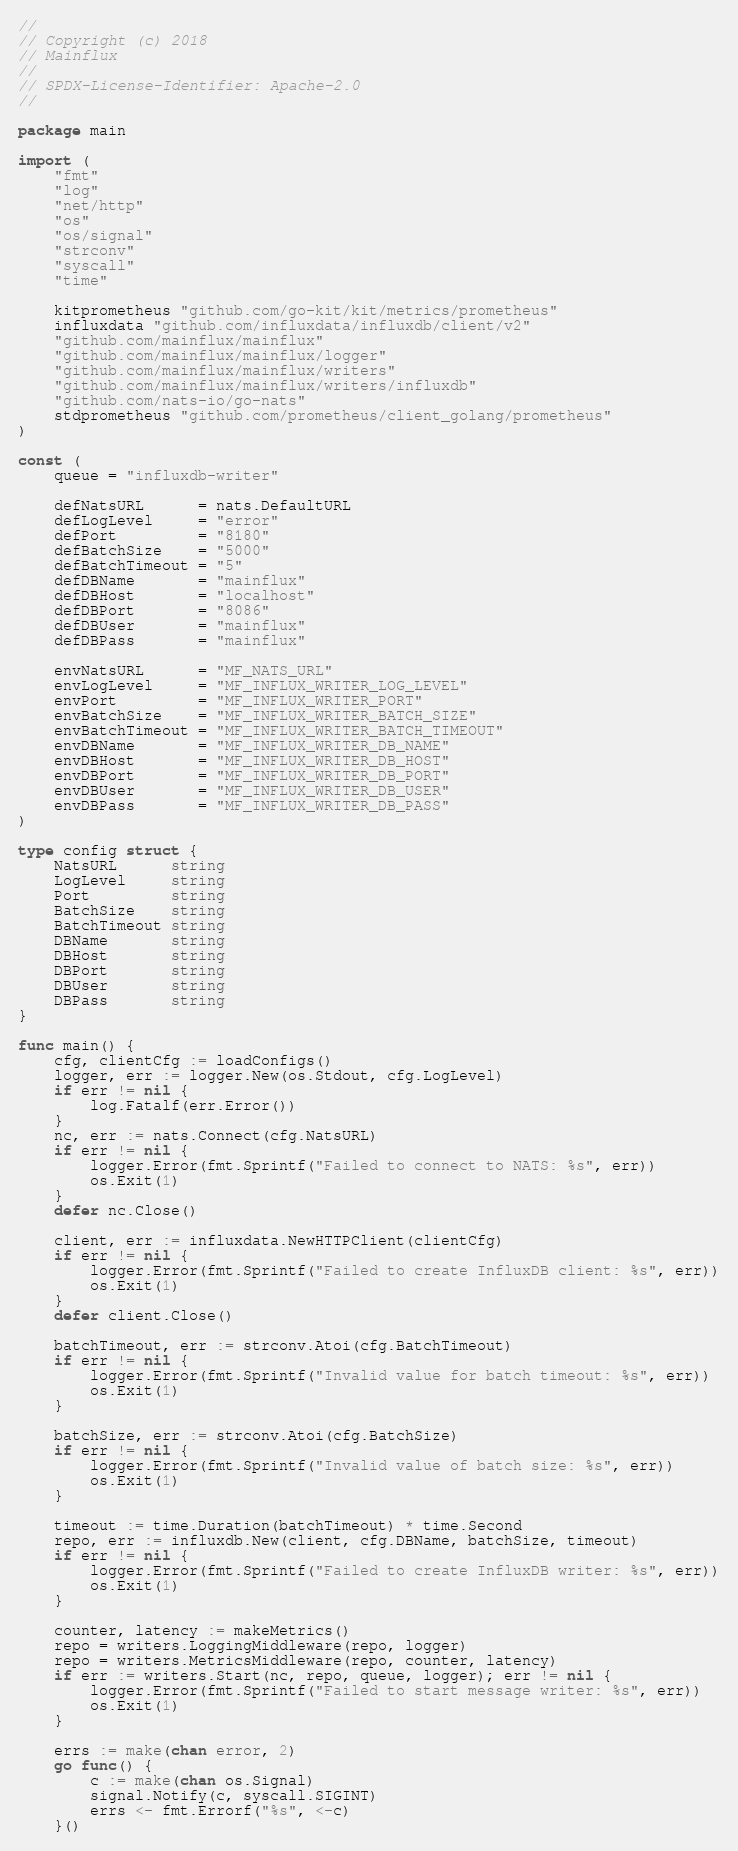Convert code to text. <code><loc_0><loc_0><loc_500><loc_500><_Go_>//
// Copyright (c) 2018
// Mainflux
//
// SPDX-License-Identifier: Apache-2.0
//

package main

import (
	"fmt"
	"log"
	"net/http"
	"os"
	"os/signal"
	"strconv"
	"syscall"
	"time"

	kitprometheus "github.com/go-kit/kit/metrics/prometheus"
	influxdata "github.com/influxdata/influxdb/client/v2"
	"github.com/mainflux/mainflux"
	"github.com/mainflux/mainflux/logger"
	"github.com/mainflux/mainflux/writers"
	"github.com/mainflux/mainflux/writers/influxdb"
	"github.com/nats-io/go-nats"
	stdprometheus "github.com/prometheus/client_golang/prometheus"
)

const (
	queue = "influxdb-writer"

	defNatsURL      = nats.DefaultURL
	defLogLevel     = "error"
	defPort         = "8180"
	defBatchSize    = "5000"
	defBatchTimeout = "5"
	defDBName       = "mainflux"
	defDBHost       = "localhost"
	defDBPort       = "8086"
	defDBUser       = "mainflux"
	defDBPass       = "mainflux"

	envNatsURL      = "MF_NATS_URL"
	envLogLevel     = "MF_INFLUX_WRITER_LOG_LEVEL"
	envPort         = "MF_INFLUX_WRITER_PORT"
	envBatchSize    = "MF_INFLUX_WRITER_BATCH_SIZE"
	envBatchTimeout = "MF_INFLUX_WRITER_BATCH_TIMEOUT"
	envDBName       = "MF_INFLUX_WRITER_DB_NAME"
	envDBHost       = "MF_INFLUX_WRITER_DB_HOST"
	envDBPort       = "MF_INFLUX_WRITER_DB_PORT"
	envDBUser       = "MF_INFLUX_WRITER_DB_USER"
	envDBPass       = "MF_INFLUX_WRITER_DB_PASS"
)

type config struct {
	NatsURL      string
	LogLevel     string
	Port         string
	BatchSize    string
	BatchTimeout string
	DBName       string
	DBHost       string
	DBPort       string
	DBUser       string
	DBPass       string
}

func main() {
	cfg, clientCfg := loadConfigs()
	logger, err := logger.New(os.Stdout, cfg.LogLevel)
	if err != nil {
		log.Fatalf(err.Error())
	}
	nc, err := nats.Connect(cfg.NatsURL)
	if err != nil {
		logger.Error(fmt.Sprintf("Failed to connect to NATS: %s", err))
		os.Exit(1)
	}
	defer nc.Close()

	client, err := influxdata.NewHTTPClient(clientCfg)
	if err != nil {
		logger.Error(fmt.Sprintf("Failed to create InfluxDB client: %s", err))
		os.Exit(1)
	}
	defer client.Close()

	batchTimeout, err := strconv.Atoi(cfg.BatchTimeout)
	if err != nil {
		logger.Error(fmt.Sprintf("Invalid value for batch timeout: %s", err))
		os.Exit(1)
	}

	batchSize, err := strconv.Atoi(cfg.BatchSize)
	if err != nil {
		logger.Error(fmt.Sprintf("Invalid value of batch size: %s", err))
		os.Exit(1)
	}

	timeout := time.Duration(batchTimeout) * time.Second
	repo, err := influxdb.New(client, cfg.DBName, batchSize, timeout)
	if err != nil {
		logger.Error(fmt.Sprintf("Failed to create InfluxDB writer: %s", err))
		os.Exit(1)
	}

	counter, latency := makeMetrics()
	repo = writers.LoggingMiddleware(repo, logger)
	repo = writers.MetricsMiddleware(repo, counter, latency)
	if err := writers.Start(nc, repo, queue, logger); err != nil {
		logger.Error(fmt.Sprintf("Failed to start message writer: %s", err))
		os.Exit(1)
	}

	errs := make(chan error, 2)
	go func() {
		c := make(chan os.Signal)
		signal.Notify(c, syscall.SIGINT)
		errs <- fmt.Errorf("%s", <-c)
	}()
</code> 